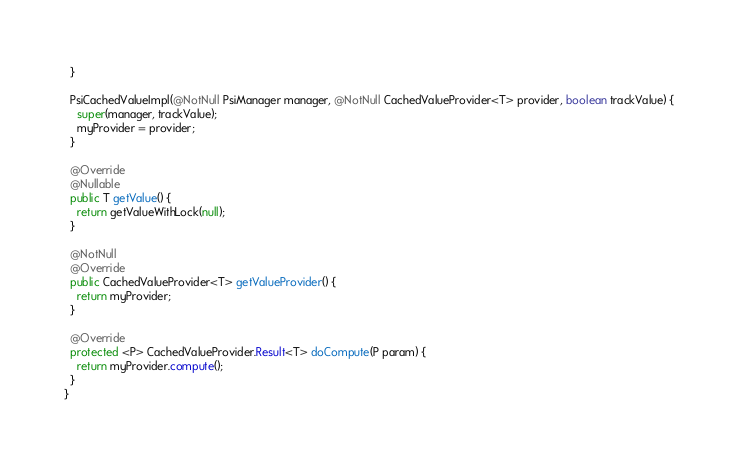Convert code to text. <code><loc_0><loc_0><loc_500><loc_500><_Java_>  }

  PsiCachedValueImpl(@NotNull PsiManager manager, @NotNull CachedValueProvider<T> provider, boolean trackValue) {
    super(manager, trackValue);
    myProvider = provider;
  }

  @Override
  @Nullable
  public T getValue() {
    return getValueWithLock(null);
  }

  @NotNull
  @Override
  public CachedValueProvider<T> getValueProvider() {
    return myProvider;
  }

  @Override
  protected <P> CachedValueProvider.Result<T> doCompute(P param) {
    return myProvider.compute();
  }
}
</code> 